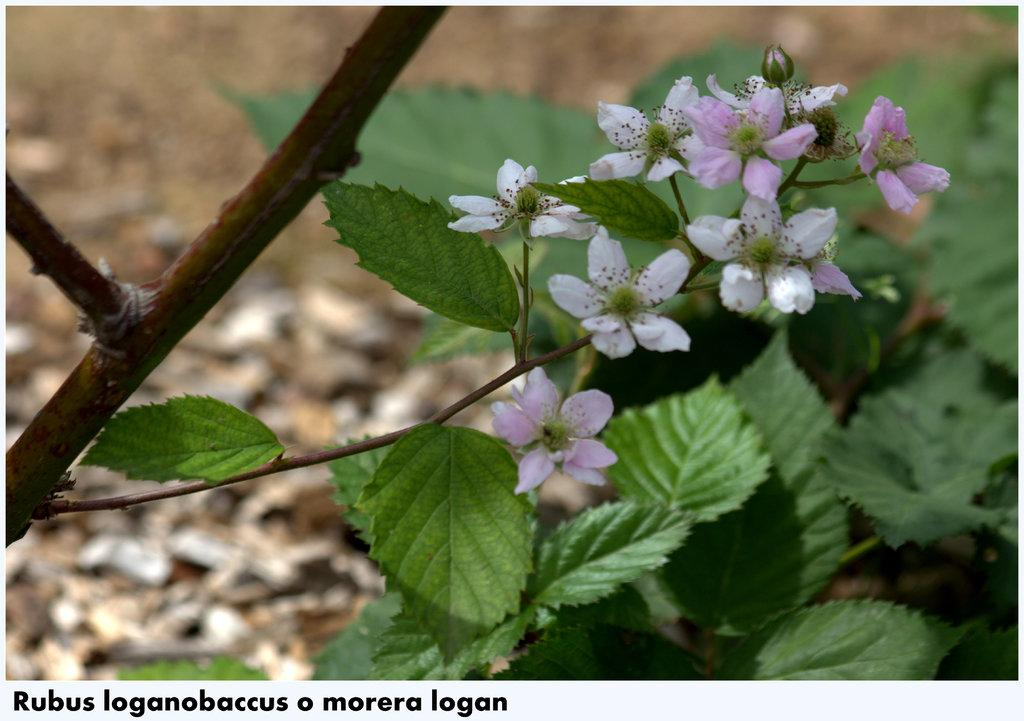What type of living organisms can be seen in the image? There are flowers and plants visible in the image. What can be observed about the background of the image? The background of the image is blurry. Is there any text present in the image? Yes, there is some text visible in the bottom left corner of the image. What type of furniture can be seen in the image? There is no furniture visible in the image; it primarily features flowers and plants. How many trucks are present in the image? There are no trucks present in the image. 